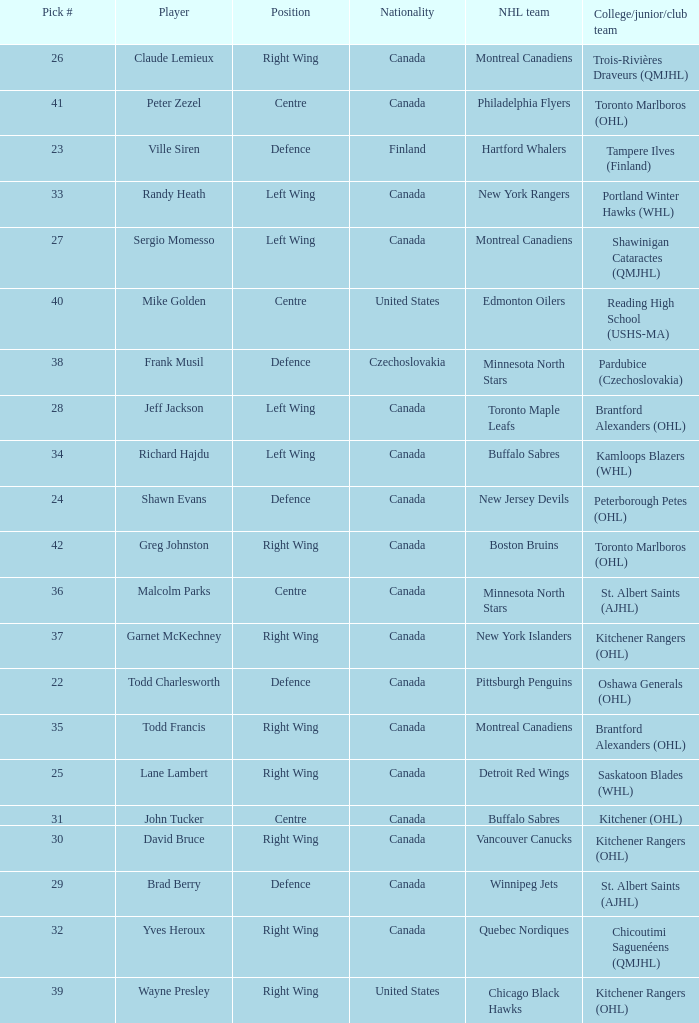What is the position for the nhl team toronto maple leafs? Left Wing. 